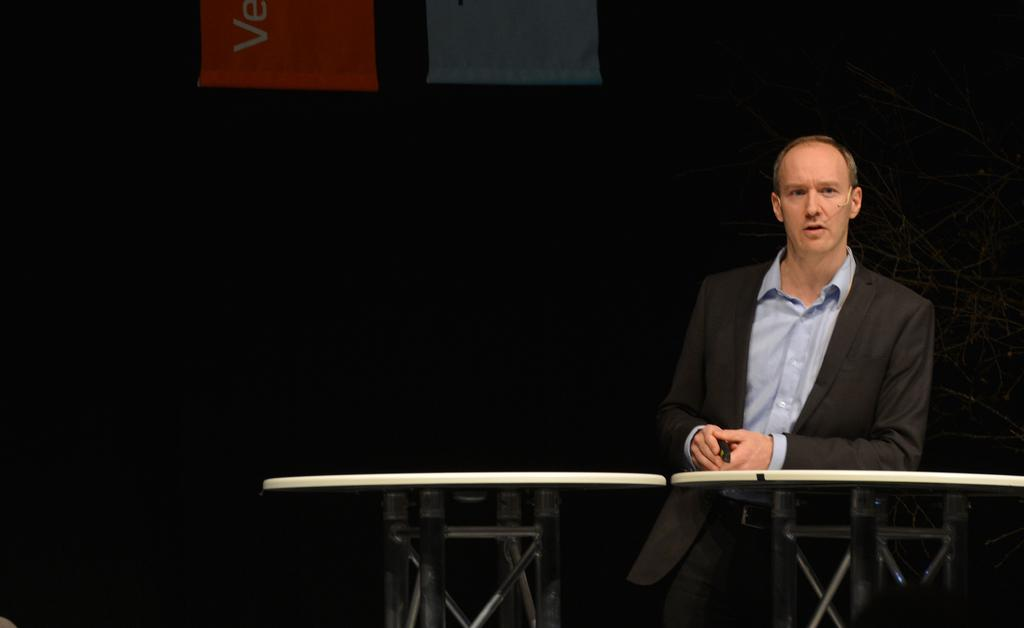Who is present in the image? There is a man in the image. What is the man wearing? The man is wearing black clothing. What can be seen behind the man? The man is standing in front of a table. What type of amusement can be seen on the roof in the image? There is no amusement or roof present in the image; it only features a man standing in front of a table. 